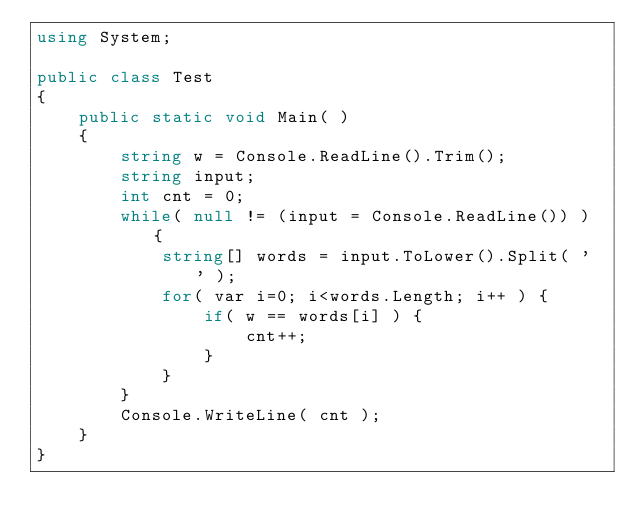<code> <loc_0><loc_0><loc_500><loc_500><_C#_>using System;

public class Test
{
	public static void Main( )
	{
		string w = Console.ReadLine().Trim();
		string input;
		int cnt = 0;
		while( null != (input = Console.ReadLine()) ) {
			string[] words = input.ToLower().Split( ' ' );
			for( var i=0; i<words.Length; i++ ) {
				if( w == words[i] ) {
					cnt++;
				}
			}
		}
		Console.WriteLine( cnt );
	}
}</code> 